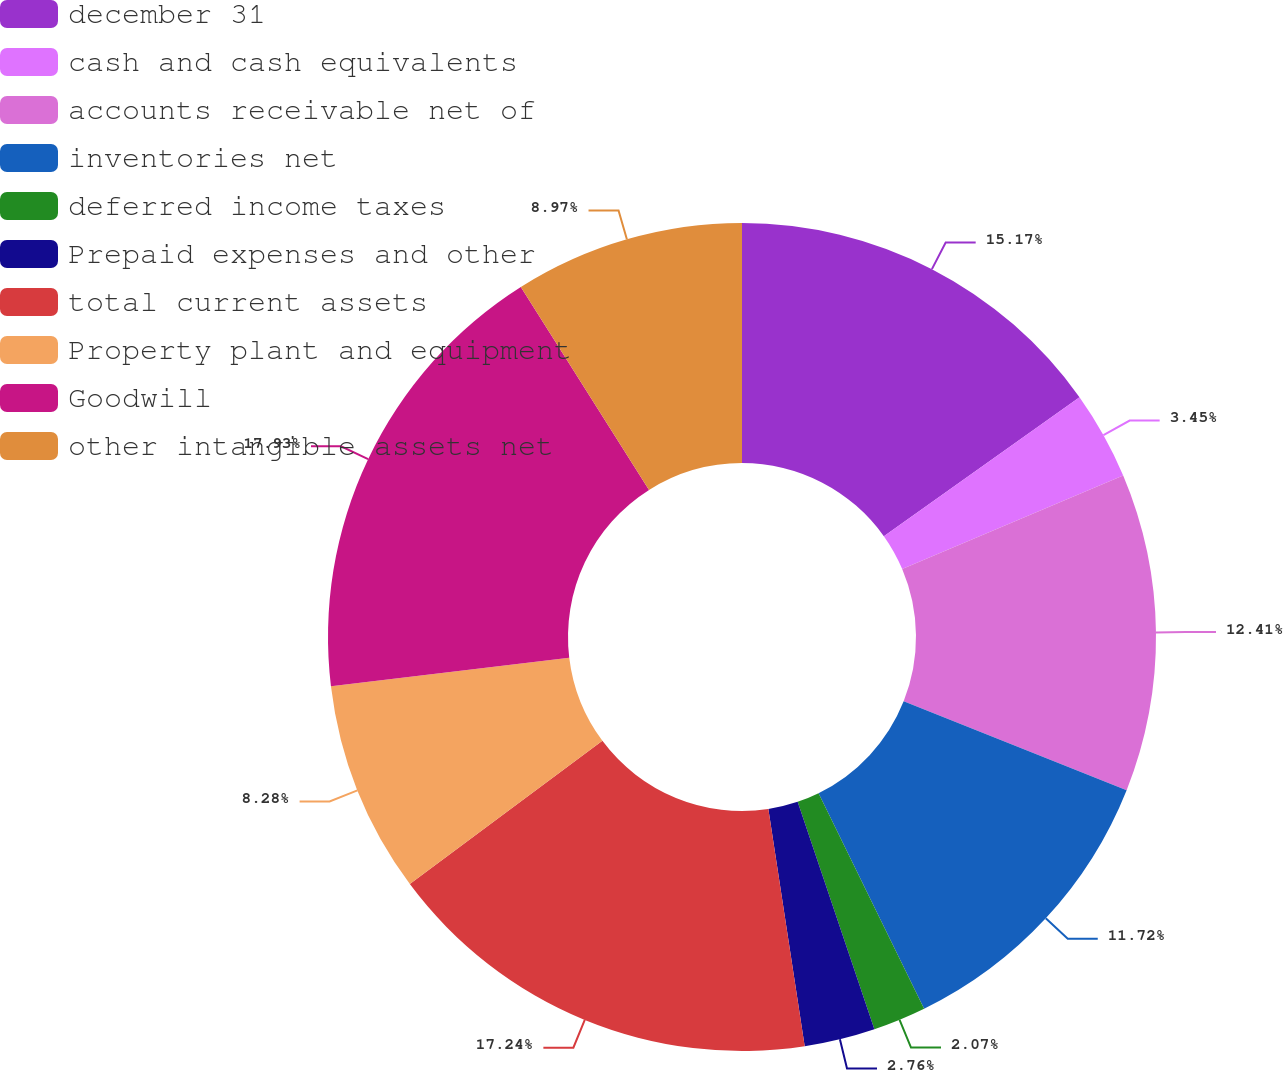Convert chart. <chart><loc_0><loc_0><loc_500><loc_500><pie_chart><fcel>december 31<fcel>cash and cash equivalents<fcel>accounts receivable net of<fcel>inventories net<fcel>deferred income taxes<fcel>Prepaid expenses and other<fcel>total current assets<fcel>Property plant and equipment<fcel>Goodwill<fcel>other intangible assets net<nl><fcel>15.17%<fcel>3.45%<fcel>12.41%<fcel>11.72%<fcel>2.07%<fcel>2.76%<fcel>17.24%<fcel>8.28%<fcel>17.93%<fcel>8.97%<nl></chart> 